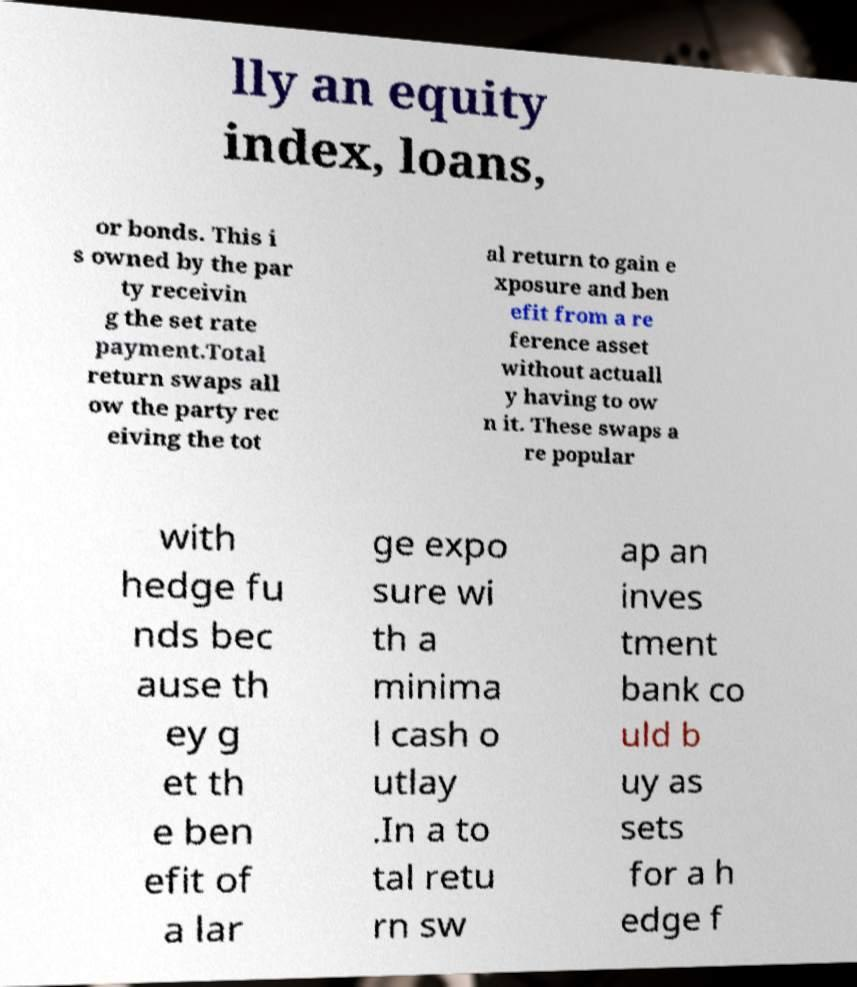For documentation purposes, I need the text within this image transcribed. Could you provide that? lly an equity index, loans, or bonds. This i s owned by the par ty receivin g the set rate payment.Total return swaps all ow the party rec eiving the tot al return to gain e xposure and ben efit from a re ference asset without actuall y having to ow n it. These swaps a re popular with hedge fu nds bec ause th ey g et th e ben efit of a lar ge expo sure wi th a minima l cash o utlay .In a to tal retu rn sw ap an inves tment bank co uld b uy as sets for a h edge f 